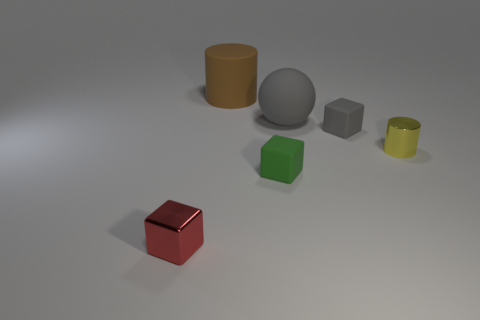Subtract all red cubes. How many cubes are left? 2 Add 2 small yellow metal cylinders. How many objects exist? 8 Subtract all blue blocks. Subtract all purple cylinders. How many blocks are left? 3 Subtract all cylinders. How many objects are left? 4 Add 1 small green things. How many small green things are left? 2 Add 6 tiny red blocks. How many tiny red blocks exist? 7 Subtract 0 cyan cubes. How many objects are left? 6 Subtract all tiny yellow objects. Subtract all matte objects. How many objects are left? 1 